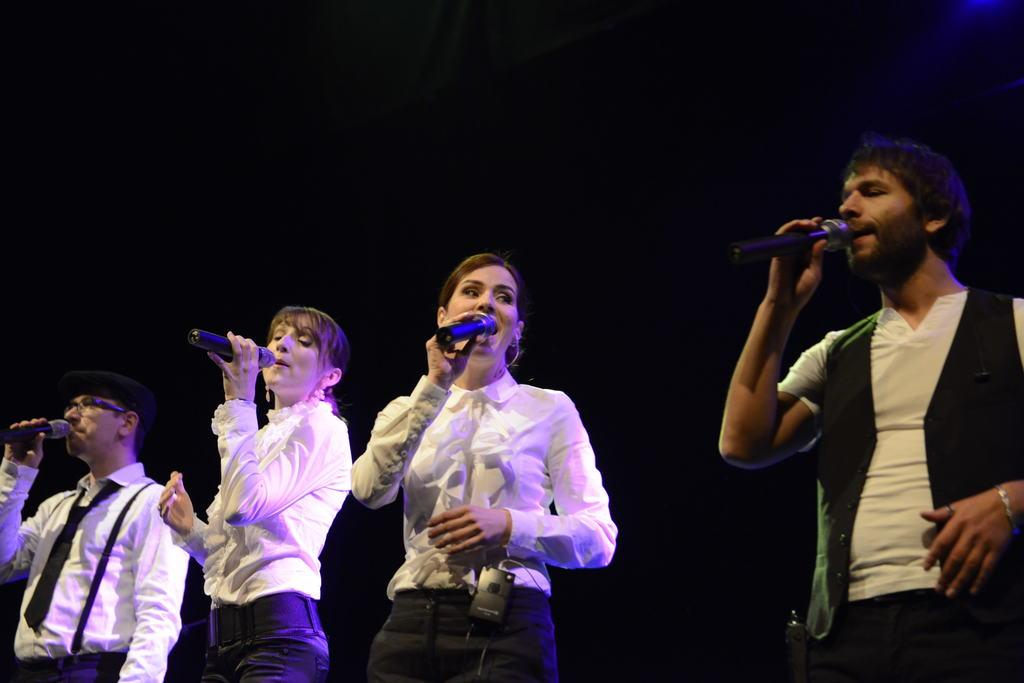How many people are in the image? There are people in the image, but the exact number is not specified. What are the people doing in the image? The people are standing and holding microphones. What color are the microphones? The microphones are black in color. What activity are the people engaged in with the microphones? The people are singing into the microphones. How much butter is being used by the people in the image? There is no mention of butter in the image, so it cannot be determined how much is being used. 